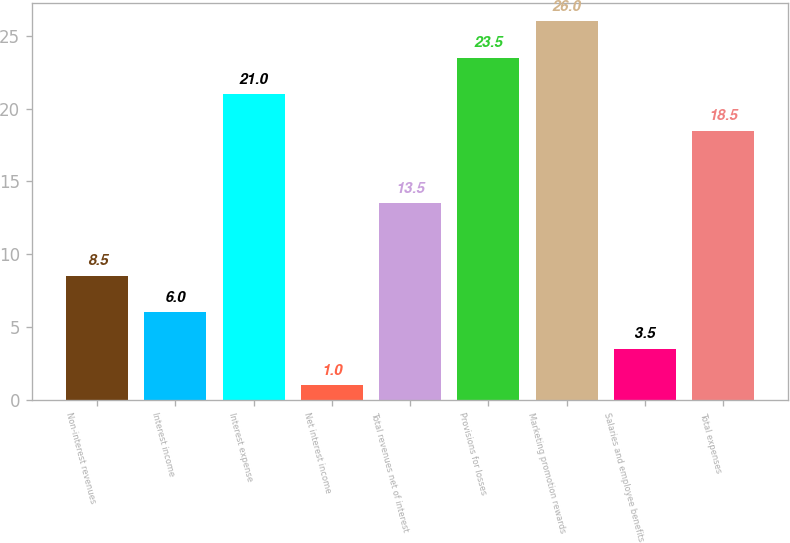Convert chart. <chart><loc_0><loc_0><loc_500><loc_500><bar_chart><fcel>Non-interest revenues<fcel>Interest income<fcel>Interest expense<fcel>Net interest income<fcel>Total revenues net of interest<fcel>Provisions for losses<fcel>Marketing promotion rewards<fcel>Salaries and employee benefits<fcel>Total expenses<nl><fcel>8.5<fcel>6<fcel>21<fcel>1<fcel>13.5<fcel>23.5<fcel>26<fcel>3.5<fcel>18.5<nl></chart> 